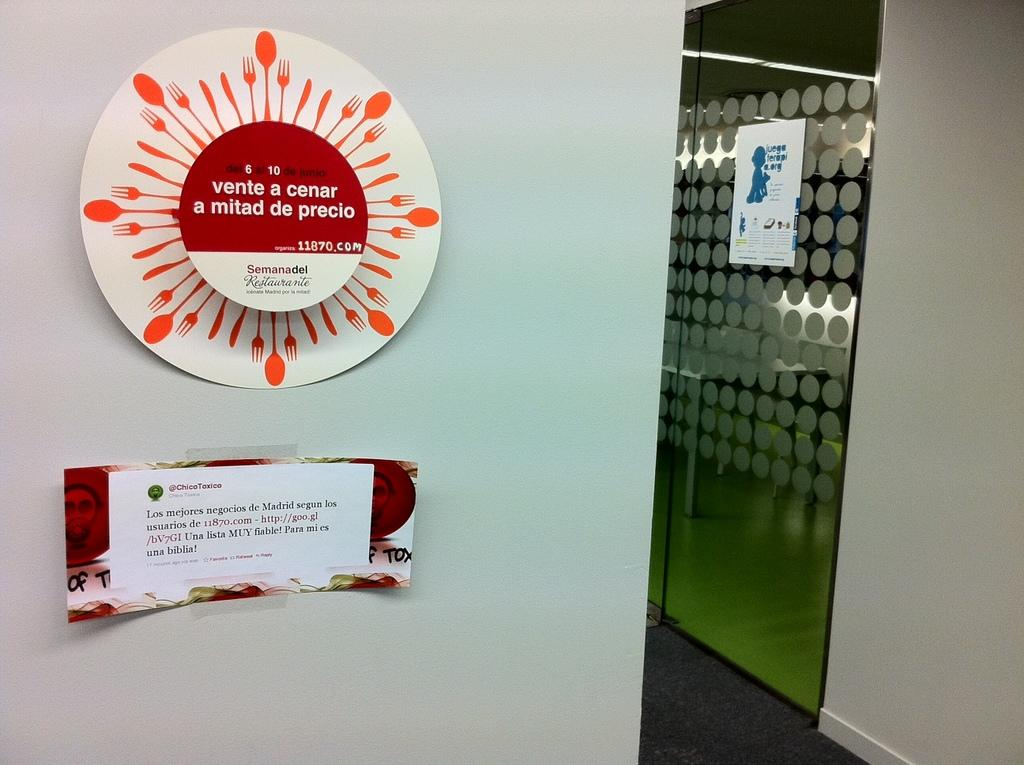What is the color of the wall in the image? The wall in the image is white. What is attached to the wall? Two papers are stuck on the wall. What is located on the right side of the image? There is a glass door on the right side of the image. What can be seen on the glass door? A white color paper is visible on the glass door. Can you see any wings on the wall in the image? There are no wings present on the wall in the image. How many stars can be seen on the glass door? There are no stars visible on the glass door in the image. 